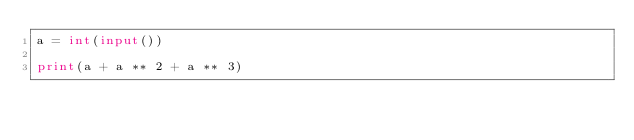Convert code to text. <code><loc_0><loc_0><loc_500><loc_500><_Python_>a = int(input())

print(a + a ** 2 + a ** 3)
</code> 